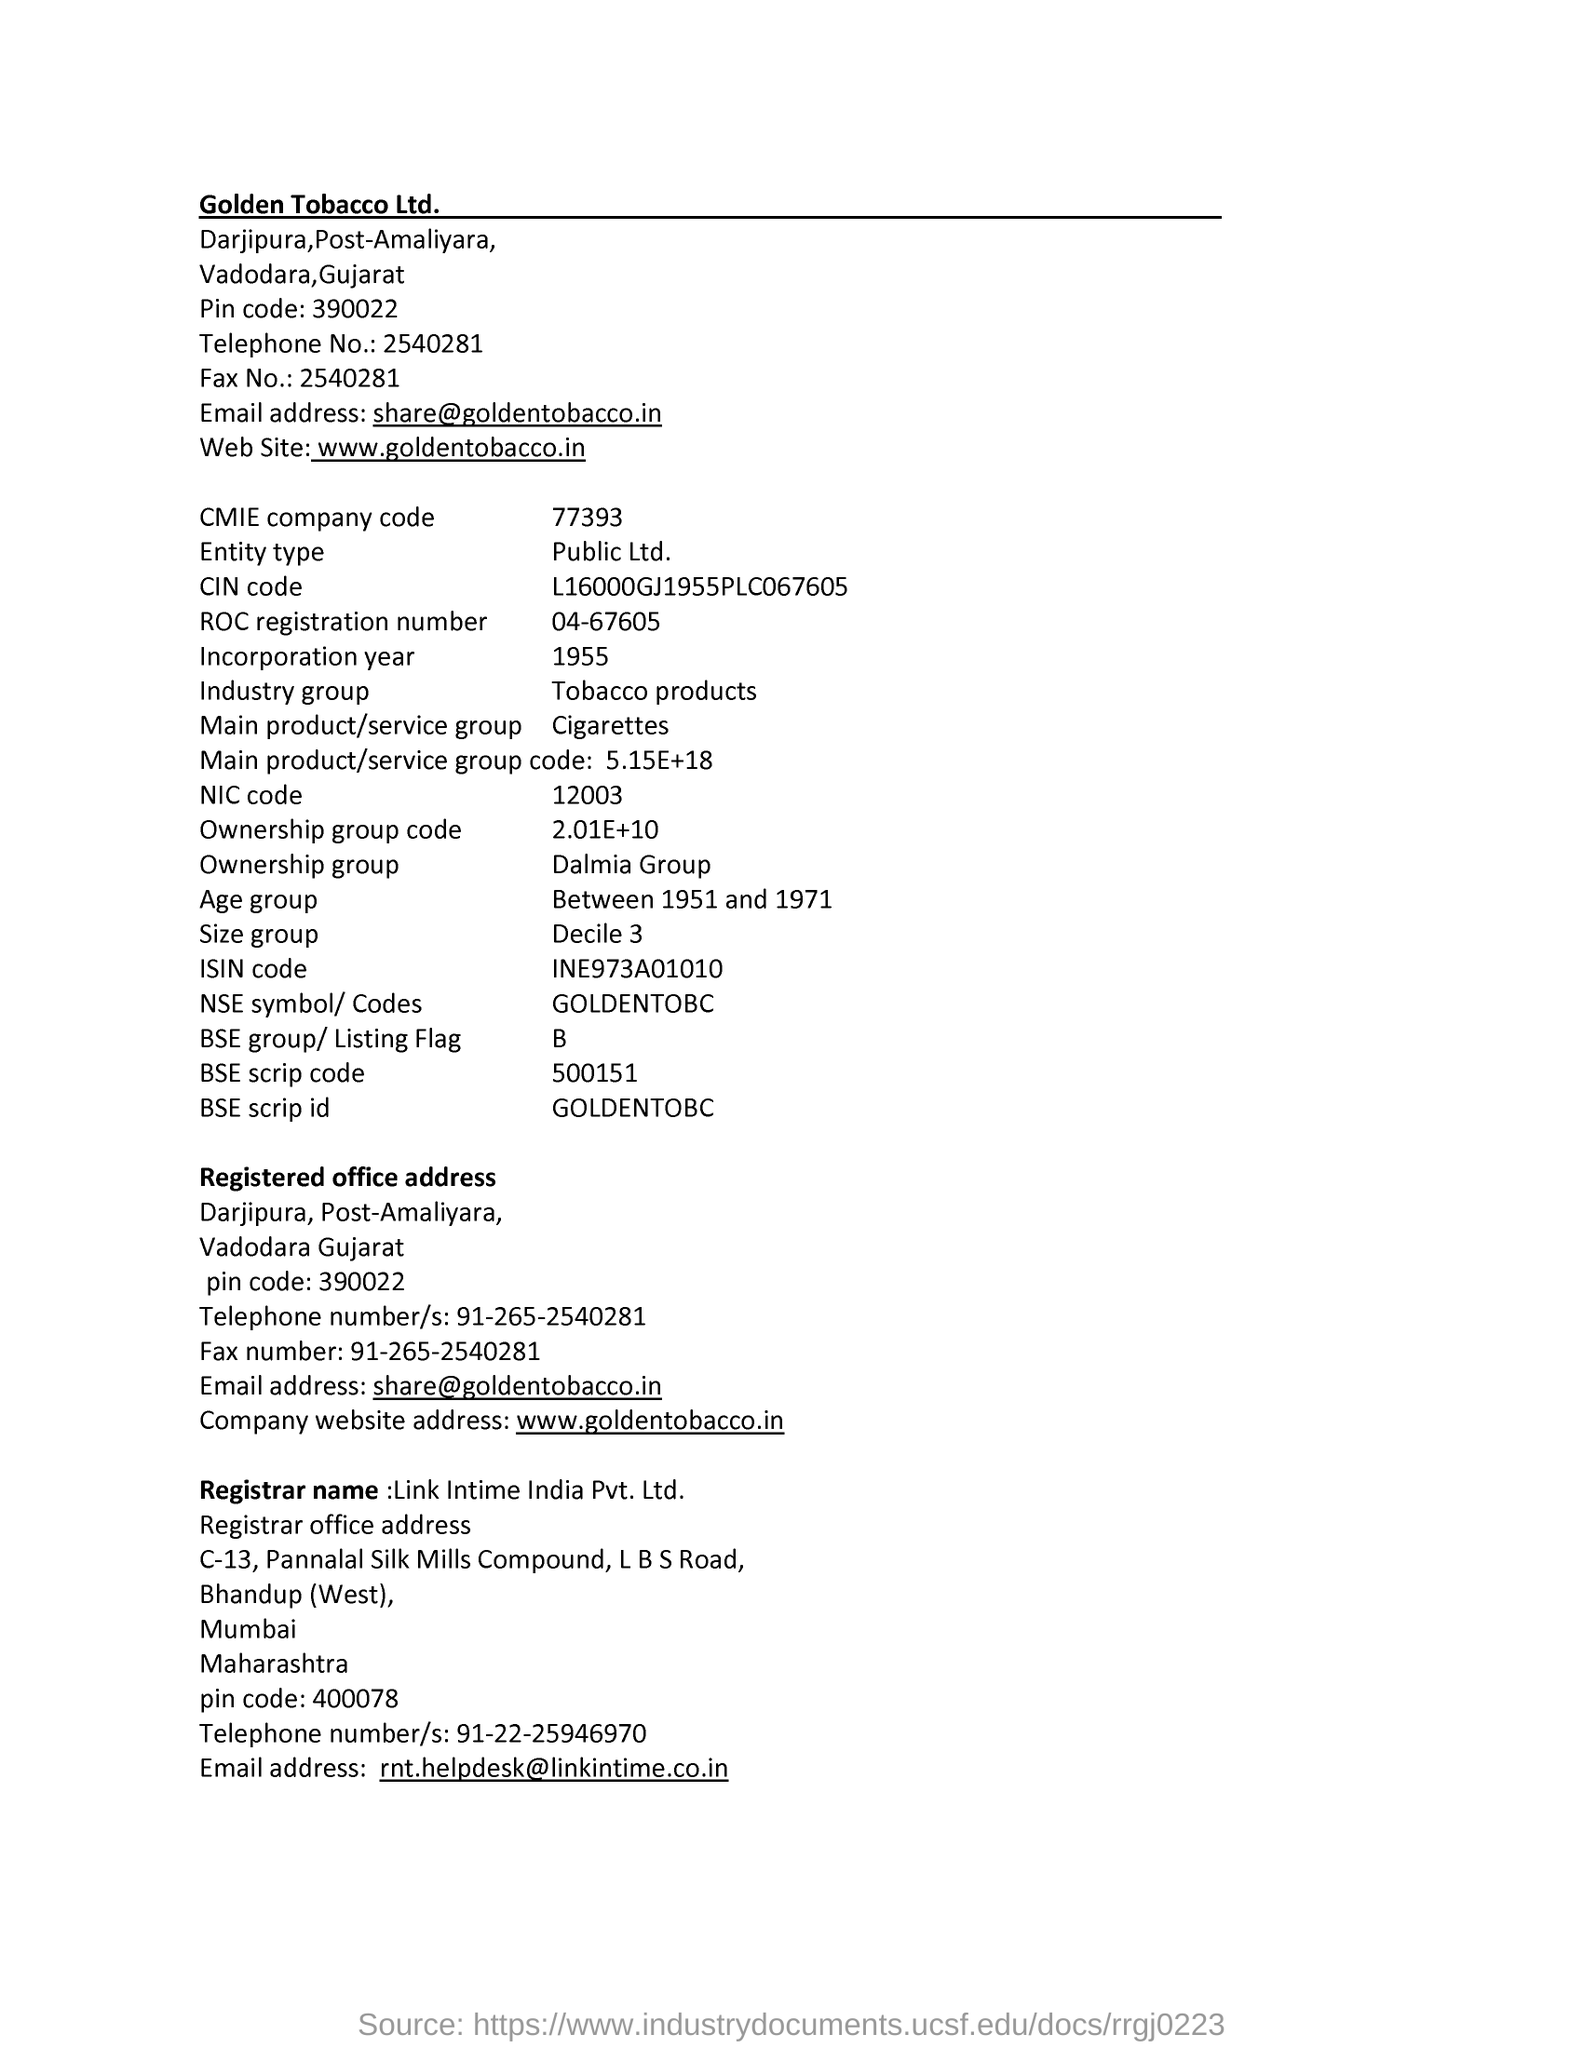What is the CMIE Company code ?
Make the answer very short. 77393. What is the BSE Scrip code ?
Provide a succinct answer. 500151. What is the NIC Code ?
Give a very brief answer. 12003. What is the Ownership group code ?
Your answer should be compact. 2.01E+10. What is the ISIN code ?
Keep it short and to the point. INE973A01010. What is the ROC registration  number ?
Offer a very short reply. 04-67605. What is the BSE group ?
Provide a succinct answer. B. What is the Industry group ?
Provide a succinct answer. Tobacco Products. 